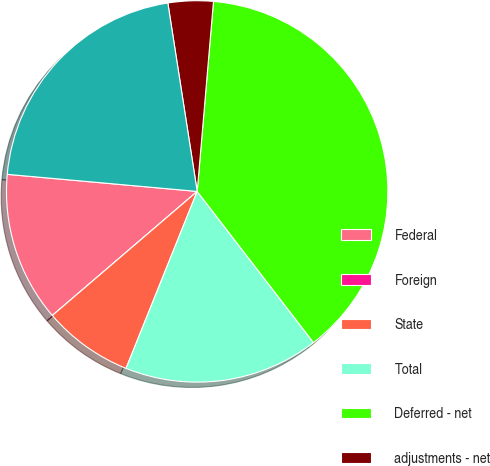<chart> <loc_0><loc_0><loc_500><loc_500><pie_chart><fcel>Federal<fcel>Foreign<fcel>State<fcel>Total<fcel>Deferred - net<fcel>adjustments - net<fcel>Income tax expense from<nl><fcel>12.7%<fcel>0.0%<fcel>7.64%<fcel>16.52%<fcel>38.2%<fcel>3.82%<fcel>21.11%<nl></chart> 